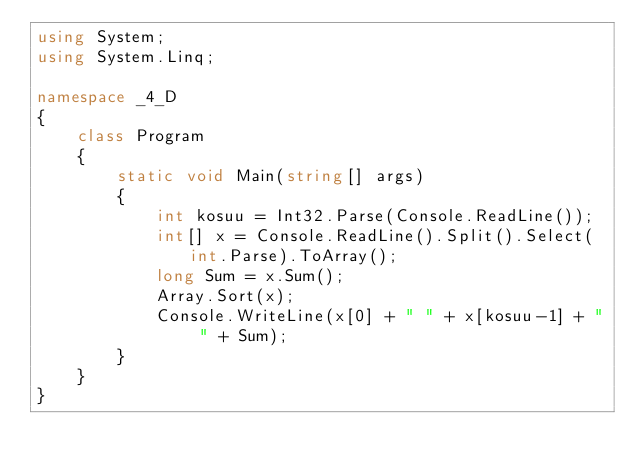Convert code to text. <code><loc_0><loc_0><loc_500><loc_500><_C#_>using System;
using System.Linq;

namespace _4_D
{
    class Program
    {
        static void Main(string[] args)
        {
            int kosuu = Int32.Parse(Console.ReadLine());
            int[] x = Console.ReadLine().Split().Select(int.Parse).ToArray();
            long Sum = x.Sum();
            Array.Sort(x);
            Console.WriteLine(x[0] + " " + x[kosuu-1] + " " + Sum);
        }
    }
}</code> 